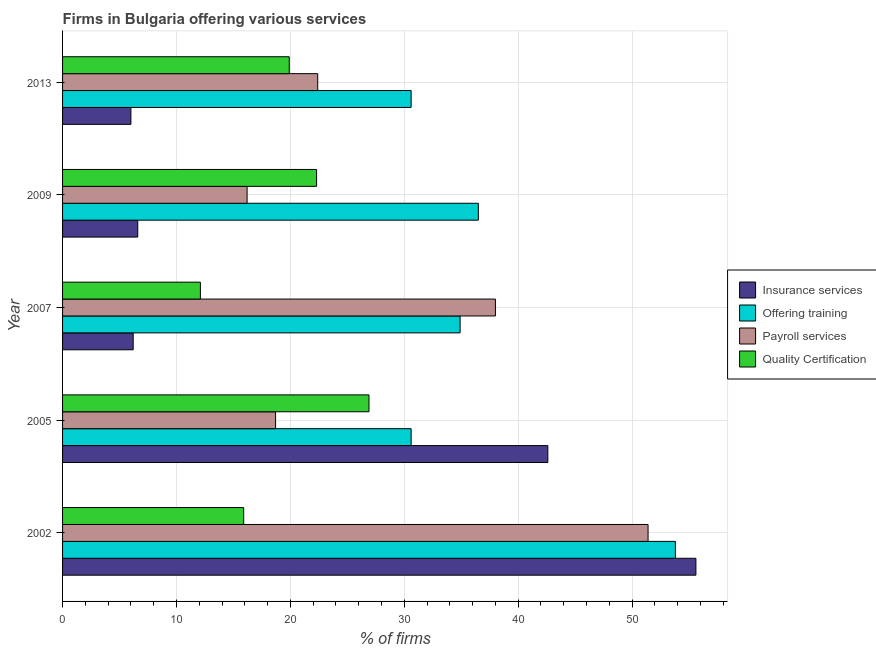Are the number of bars per tick equal to the number of legend labels?
Provide a succinct answer. Yes. Are the number of bars on each tick of the Y-axis equal?
Your answer should be very brief. Yes. How many bars are there on the 3rd tick from the top?
Give a very brief answer. 4. How many bars are there on the 3rd tick from the bottom?
Your response must be concise. 4. What is the label of the 5th group of bars from the top?
Your answer should be very brief. 2002. In how many cases, is the number of bars for a given year not equal to the number of legend labels?
Offer a very short reply. 0. What is the percentage of firms offering insurance services in 2002?
Your response must be concise. 55.6. Across all years, what is the maximum percentage of firms offering training?
Offer a very short reply. 53.8. In which year was the percentage of firms offering training maximum?
Provide a short and direct response. 2002. In which year was the percentage of firms offering payroll services minimum?
Your answer should be very brief. 2009. What is the total percentage of firms offering training in the graph?
Give a very brief answer. 186.4. What is the average percentage of firms offering payroll services per year?
Provide a succinct answer. 29.34. In the year 2007, what is the difference between the percentage of firms offering training and percentage of firms offering insurance services?
Your answer should be compact. 28.7. What is the ratio of the percentage of firms offering insurance services in 2002 to that in 2005?
Make the answer very short. 1.3. What is the difference between the highest and the lowest percentage of firms offering insurance services?
Offer a very short reply. 49.6. In how many years, is the percentage of firms offering insurance services greater than the average percentage of firms offering insurance services taken over all years?
Provide a succinct answer. 2. What does the 3rd bar from the top in 2007 represents?
Your answer should be very brief. Offering training. What does the 2nd bar from the bottom in 2009 represents?
Give a very brief answer. Offering training. How many bars are there?
Offer a terse response. 20. How many years are there in the graph?
Keep it short and to the point. 5. What is the difference between two consecutive major ticks on the X-axis?
Your answer should be compact. 10. Where does the legend appear in the graph?
Offer a very short reply. Center right. How are the legend labels stacked?
Provide a succinct answer. Vertical. What is the title of the graph?
Keep it short and to the point. Firms in Bulgaria offering various services . Does "Austria" appear as one of the legend labels in the graph?
Keep it short and to the point. No. What is the label or title of the X-axis?
Provide a short and direct response. % of firms. What is the label or title of the Y-axis?
Offer a very short reply. Year. What is the % of firms of Insurance services in 2002?
Provide a succinct answer. 55.6. What is the % of firms in Offering training in 2002?
Your answer should be very brief. 53.8. What is the % of firms in Payroll services in 2002?
Your answer should be compact. 51.4. What is the % of firms of Insurance services in 2005?
Offer a terse response. 42.6. What is the % of firms of Offering training in 2005?
Keep it short and to the point. 30.6. What is the % of firms of Payroll services in 2005?
Make the answer very short. 18.7. What is the % of firms of Quality Certification in 2005?
Your answer should be very brief. 26.9. What is the % of firms in Insurance services in 2007?
Keep it short and to the point. 6.2. What is the % of firms in Offering training in 2007?
Your answer should be compact. 34.9. What is the % of firms of Payroll services in 2007?
Give a very brief answer. 38. What is the % of firms of Insurance services in 2009?
Your response must be concise. 6.6. What is the % of firms in Offering training in 2009?
Ensure brevity in your answer.  36.5. What is the % of firms in Quality Certification in 2009?
Your response must be concise. 22.3. What is the % of firms in Insurance services in 2013?
Offer a very short reply. 6. What is the % of firms in Offering training in 2013?
Your answer should be very brief. 30.6. What is the % of firms in Payroll services in 2013?
Provide a short and direct response. 22.4. What is the % of firms in Quality Certification in 2013?
Keep it short and to the point. 19.9. Across all years, what is the maximum % of firms in Insurance services?
Make the answer very short. 55.6. Across all years, what is the maximum % of firms of Offering training?
Give a very brief answer. 53.8. Across all years, what is the maximum % of firms in Payroll services?
Provide a short and direct response. 51.4. Across all years, what is the maximum % of firms in Quality Certification?
Provide a succinct answer. 26.9. Across all years, what is the minimum % of firms of Insurance services?
Keep it short and to the point. 6. Across all years, what is the minimum % of firms in Offering training?
Your response must be concise. 30.6. Across all years, what is the minimum % of firms of Payroll services?
Your response must be concise. 16.2. Across all years, what is the minimum % of firms in Quality Certification?
Make the answer very short. 12.1. What is the total % of firms of Insurance services in the graph?
Your answer should be compact. 117. What is the total % of firms of Offering training in the graph?
Your answer should be compact. 186.4. What is the total % of firms of Payroll services in the graph?
Make the answer very short. 146.7. What is the total % of firms in Quality Certification in the graph?
Offer a very short reply. 97.1. What is the difference between the % of firms in Insurance services in 2002 and that in 2005?
Your response must be concise. 13. What is the difference between the % of firms in Offering training in 2002 and that in 2005?
Give a very brief answer. 23.2. What is the difference between the % of firms of Payroll services in 2002 and that in 2005?
Provide a succinct answer. 32.7. What is the difference between the % of firms of Quality Certification in 2002 and that in 2005?
Make the answer very short. -11. What is the difference between the % of firms of Insurance services in 2002 and that in 2007?
Your answer should be compact. 49.4. What is the difference between the % of firms of Payroll services in 2002 and that in 2007?
Offer a very short reply. 13.4. What is the difference between the % of firms of Quality Certification in 2002 and that in 2007?
Keep it short and to the point. 3.8. What is the difference between the % of firms in Payroll services in 2002 and that in 2009?
Offer a terse response. 35.2. What is the difference between the % of firms in Insurance services in 2002 and that in 2013?
Your answer should be compact. 49.6. What is the difference between the % of firms of Offering training in 2002 and that in 2013?
Give a very brief answer. 23.2. What is the difference between the % of firms in Payroll services in 2002 and that in 2013?
Your answer should be compact. 29. What is the difference between the % of firms of Insurance services in 2005 and that in 2007?
Your answer should be compact. 36.4. What is the difference between the % of firms in Offering training in 2005 and that in 2007?
Keep it short and to the point. -4.3. What is the difference between the % of firms of Payroll services in 2005 and that in 2007?
Keep it short and to the point. -19.3. What is the difference between the % of firms of Quality Certification in 2005 and that in 2007?
Offer a very short reply. 14.8. What is the difference between the % of firms of Insurance services in 2005 and that in 2013?
Keep it short and to the point. 36.6. What is the difference between the % of firms in Offering training in 2005 and that in 2013?
Make the answer very short. 0. What is the difference between the % of firms in Quality Certification in 2005 and that in 2013?
Provide a short and direct response. 7. What is the difference between the % of firms in Payroll services in 2007 and that in 2009?
Provide a short and direct response. 21.8. What is the difference between the % of firms of Quality Certification in 2007 and that in 2009?
Your response must be concise. -10.2. What is the difference between the % of firms of Offering training in 2007 and that in 2013?
Offer a terse response. 4.3. What is the difference between the % of firms of Payroll services in 2007 and that in 2013?
Give a very brief answer. 15.6. What is the difference between the % of firms in Insurance services in 2009 and that in 2013?
Give a very brief answer. 0.6. What is the difference between the % of firms of Payroll services in 2009 and that in 2013?
Keep it short and to the point. -6.2. What is the difference between the % of firms in Quality Certification in 2009 and that in 2013?
Offer a very short reply. 2.4. What is the difference between the % of firms of Insurance services in 2002 and the % of firms of Offering training in 2005?
Ensure brevity in your answer.  25. What is the difference between the % of firms of Insurance services in 2002 and the % of firms of Payroll services in 2005?
Make the answer very short. 36.9. What is the difference between the % of firms of Insurance services in 2002 and the % of firms of Quality Certification in 2005?
Your answer should be very brief. 28.7. What is the difference between the % of firms in Offering training in 2002 and the % of firms in Payroll services in 2005?
Offer a terse response. 35.1. What is the difference between the % of firms of Offering training in 2002 and the % of firms of Quality Certification in 2005?
Ensure brevity in your answer.  26.9. What is the difference between the % of firms in Insurance services in 2002 and the % of firms in Offering training in 2007?
Offer a terse response. 20.7. What is the difference between the % of firms in Insurance services in 2002 and the % of firms in Quality Certification in 2007?
Your response must be concise. 43.5. What is the difference between the % of firms of Offering training in 2002 and the % of firms of Quality Certification in 2007?
Make the answer very short. 41.7. What is the difference between the % of firms of Payroll services in 2002 and the % of firms of Quality Certification in 2007?
Provide a succinct answer. 39.3. What is the difference between the % of firms of Insurance services in 2002 and the % of firms of Payroll services in 2009?
Your response must be concise. 39.4. What is the difference between the % of firms in Insurance services in 2002 and the % of firms in Quality Certification in 2009?
Provide a short and direct response. 33.3. What is the difference between the % of firms of Offering training in 2002 and the % of firms of Payroll services in 2009?
Your response must be concise. 37.6. What is the difference between the % of firms of Offering training in 2002 and the % of firms of Quality Certification in 2009?
Provide a succinct answer. 31.5. What is the difference between the % of firms of Payroll services in 2002 and the % of firms of Quality Certification in 2009?
Give a very brief answer. 29.1. What is the difference between the % of firms in Insurance services in 2002 and the % of firms in Offering training in 2013?
Ensure brevity in your answer.  25. What is the difference between the % of firms of Insurance services in 2002 and the % of firms of Payroll services in 2013?
Offer a terse response. 33.2. What is the difference between the % of firms in Insurance services in 2002 and the % of firms in Quality Certification in 2013?
Your answer should be very brief. 35.7. What is the difference between the % of firms of Offering training in 2002 and the % of firms of Payroll services in 2013?
Ensure brevity in your answer.  31.4. What is the difference between the % of firms in Offering training in 2002 and the % of firms in Quality Certification in 2013?
Make the answer very short. 33.9. What is the difference between the % of firms in Payroll services in 2002 and the % of firms in Quality Certification in 2013?
Offer a terse response. 31.5. What is the difference between the % of firms of Insurance services in 2005 and the % of firms of Offering training in 2007?
Give a very brief answer. 7.7. What is the difference between the % of firms of Insurance services in 2005 and the % of firms of Payroll services in 2007?
Make the answer very short. 4.6. What is the difference between the % of firms of Insurance services in 2005 and the % of firms of Quality Certification in 2007?
Offer a terse response. 30.5. What is the difference between the % of firms of Payroll services in 2005 and the % of firms of Quality Certification in 2007?
Provide a short and direct response. 6.6. What is the difference between the % of firms in Insurance services in 2005 and the % of firms in Offering training in 2009?
Give a very brief answer. 6.1. What is the difference between the % of firms of Insurance services in 2005 and the % of firms of Payroll services in 2009?
Your answer should be compact. 26.4. What is the difference between the % of firms in Insurance services in 2005 and the % of firms in Quality Certification in 2009?
Make the answer very short. 20.3. What is the difference between the % of firms in Insurance services in 2005 and the % of firms in Payroll services in 2013?
Your response must be concise. 20.2. What is the difference between the % of firms in Insurance services in 2005 and the % of firms in Quality Certification in 2013?
Ensure brevity in your answer.  22.7. What is the difference between the % of firms in Offering training in 2005 and the % of firms in Quality Certification in 2013?
Provide a succinct answer. 10.7. What is the difference between the % of firms of Insurance services in 2007 and the % of firms of Offering training in 2009?
Offer a very short reply. -30.3. What is the difference between the % of firms of Insurance services in 2007 and the % of firms of Payroll services in 2009?
Ensure brevity in your answer.  -10. What is the difference between the % of firms in Insurance services in 2007 and the % of firms in Quality Certification in 2009?
Your answer should be compact. -16.1. What is the difference between the % of firms of Offering training in 2007 and the % of firms of Payroll services in 2009?
Keep it short and to the point. 18.7. What is the difference between the % of firms of Offering training in 2007 and the % of firms of Quality Certification in 2009?
Your answer should be compact. 12.6. What is the difference between the % of firms in Insurance services in 2007 and the % of firms in Offering training in 2013?
Keep it short and to the point. -24.4. What is the difference between the % of firms in Insurance services in 2007 and the % of firms in Payroll services in 2013?
Offer a very short reply. -16.2. What is the difference between the % of firms of Insurance services in 2007 and the % of firms of Quality Certification in 2013?
Offer a very short reply. -13.7. What is the difference between the % of firms in Payroll services in 2007 and the % of firms in Quality Certification in 2013?
Your response must be concise. 18.1. What is the difference between the % of firms of Insurance services in 2009 and the % of firms of Payroll services in 2013?
Your answer should be compact. -15.8. What is the difference between the % of firms of Offering training in 2009 and the % of firms of Quality Certification in 2013?
Offer a very short reply. 16.6. What is the average % of firms of Insurance services per year?
Provide a short and direct response. 23.4. What is the average % of firms of Offering training per year?
Your answer should be compact. 37.28. What is the average % of firms in Payroll services per year?
Provide a succinct answer. 29.34. What is the average % of firms in Quality Certification per year?
Your response must be concise. 19.42. In the year 2002, what is the difference between the % of firms in Insurance services and % of firms in Offering training?
Provide a short and direct response. 1.8. In the year 2002, what is the difference between the % of firms of Insurance services and % of firms of Payroll services?
Provide a succinct answer. 4.2. In the year 2002, what is the difference between the % of firms in Insurance services and % of firms in Quality Certification?
Provide a short and direct response. 39.7. In the year 2002, what is the difference between the % of firms of Offering training and % of firms of Quality Certification?
Provide a short and direct response. 37.9. In the year 2002, what is the difference between the % of firms in Payroll services and % of firms in Quality Certification?
Provide a short and direct response. 35.5. In the year 2005, what is the difference between the % of firms of Insurance services and % of firms of Payroll services?
Offer a very short reply. 23.9. In the year 2005, what is the difference between the % of firms in Insurance services and % of firms in Quality Certification?
Ensure brevity in your answer.  15.7. In the year 2005, what is the difference between the % of firms in Offering training and % of firms in Payroll services?
Offer a very short reply. 11.9. In the year 2005, what is the difference between the % of firms of Offering training and % of firms of Quality Certification?
Ensure brevity in your answer.  3.7. In the year 2007, what is the difference between the % of firms of Insurance services and % of firms of Offering training?
Keep it short and to the point. -28.7. In the year 2007, what is the difference between the % of firms of Insurance services and % of firms of Payroll services?
Keep it short and to the point. -31.8. In the year 2007, what is the difference between the % of firms of Insurance services and % of firms of Quality Certification?
Keep it short and to the point. -5.9. In the year 2007, what is the difference between the % of firms of Offering training and % of firms of Quality Certification?
Your answer should be compact. 22.8. In the year 2007, what is the difference between the % of firms in Payroll services and % of firms in Quality Certification?
Ensure brevity in your answer.  25.9. In the year 2009, what is the difference between the % of firms in Insurance services and % of firms in Offering training?
Keep it short and to the point. -29.9. In the year 2009, what is the difference between the % of firms in Insurance services and % of firms in Payroll services?
Your answer should be very brief. -9.6. In the year 2009, what is the difference between the % of firms of Insurance services and % of firms of Quality Certification?
Offer a terse response. -15.7. In the year 2009, what is the difference between the % of firms in Offering training and % of firms in Payroll services?
Ensure brevity in your answer.  20.3. In the year 2013, what is the difference between the % of firms in Insurance services and % of firms in Offering training?
Offer a terse response. -24.6. In the year 2013, what is the difference between the % of firms in Insurance services and % of firms in Payroll services?
Provide a short and direct response. -16.4. In the year 2013, what is the difference between the % of firms of Insurance services and % of firms of Quality Certification?
Make the answer very short. -13.9. In the year 2013, what is the difference between the % of firms in Offering training and % of firms in Payroll services?
Your answer should be compact. 8.2. In the year 2013, what is the difference between the % of firms in Offering training and % of firms in Quality Certification?
Your response must be concise. 10.7. In the year 2013, what is the difference between the % of firms of Payroll services and % of firms of Quality Certification?
Provide a short and direct response. 2.5. What is the ratio of the % of firms in Insurance services in 2002 to that in 2005?
Offer a very short reply. 1.31. What is the ratio of the % of firms of Offering training in 2002 to that in 2005?
Give a very brief answer. 1.76. What is the ratio of the % of firms in Payroll services in 2002 to that in 2005?
Your answer should be compact. 2.75. What is the ratio of the % of firms in Quality Certification in 2002 to that in 2005?
Keep it short and to the point. 0.59. What is the ratio of the % of firms in Insurance services in 2002 to that in 2007?
Your response must be concise. 8.97. What is the ratio of the % of firms in Offering training in 2002 to that in 2007?
Make the answer very short. 1.54. What is the ratio of the % of firms of Payroll services in 2002 to that in 2007?
Your response must be concise. 1.35. What is the ratio of the % of firms in Quality Certification in 2002 to that in 2007?
Ensure brevity in your answer.  1.31. What is the ratio of the % of firms in Insurance services in 2002 to that in 2009?
Keep it short and to the point. 8.42. What is the ratio of the % of firms of Offering training in 2002 to that in 2009?
Your response must be concise. 1.47. What is the ratio of the % of firms in Payroll services in 2002 to that in 2009?
Provide a succinct answer. 3.17. What is the ratio of the % of firms in Quality Certification in 2002 to that in 2009?
Offer a terse response. 0.71. What is the ratio of the % of firms of Insurance services in 2002 to that in 2013?
Offer a terse response. 9.27. What is the ratio of the % of firms in Offering training in 2002 to that in 2013?
Give a very brief answer. 1.76. What is the ratio of the % of firms in Payroll services in 2002 to that in 2013?
Your answer should be very brief. 2.29. What is the ratio of the % of firms of Quality Certification in 2002 to that in 2013?
Keep it short and to the point. 0.8. What is the ratio of the % of firms in Insurance services in 2005 to that in 2007?
Your answer should be very brief. 6.87. What is the ratio of the % of firms in Offering training in 2005 to that in 2007?
Your answer should be very brief. 0.88. What is the ratio of the % of firms of Payroll services in 2005 to that in 2007?
Offer a very short reply. 0.49. What is the ratio of the % of firms of Quality Certification in 2005 to that in 2007?
Provide a short and direct response. 2.22. What is the ratio of the % of firms in Insurance services in 2005 to that in 2009?
Your answer should be very brief. 6.45. What is the ratio of the % of firms of Offering training in 2005 to that in 2009?
Your response must be concise. 0.84. What is the ratio of the % of firms in Payroll services in 2005 to that in 2009?
Your answer should be compact. 1.15. What is the ratio of the % of firms in Quality Certification in 2005 to that in 2009?
Offer a very short reply. 1.21. What is the ratio of the % of firms of Payroll services in 2005 to that in 2013?
Keep it short and to the point. 0.83. What is the ratio of the % of firms of Quality Certification in 2005 to that in 2013?
Your answer should be very brief. 1.35. What is the ratio of the % of firms of Insurance services in 2007 to that in 2009?
Your answer should be very brief. 0.94. What is the ratio of the % of firms in Offering training in 2007 to that in 2009?
Make the answer very short. 0.96. What is the ratio of the % of firms in Payroll services in 2007 to that in 2009?
Your answer should be very brief. 2.35. What is the ratio of the % of firms in Quality Certification in 2007 to that in 2009?
Provide a short and direct response. 0.54. What is the ratio of the % of firms in Insurance services in 2007 to that in 2013?
Your answer should be very brief. 1.03. What is the ratio of the % of firms of Offering training in 2007 to that in 2013?
Your response must be concise. 1.14. What is the ratio of the % of firms of Payroll services in 2007 to that in 2013?
Provide a short and direct response. 1.7. What is the ratio of the % of firms in Quality Certification in 2007 to that in 2013?
Offer a very short reply. 0.61. What is the ratio of the % of firms of Offering training in 2009 to that in 2013?
Provide a short and direct response. 1.19. What is the ratio of the % of firms in Payroll services in 2009 to that in 2013?
Your answer should be very brief. 0.72. What is the ratio of the % of firms in Quality Certification in 2009 to that in 2013?
Offer a terse response. 1.12. What is the difference between the highest and the second highest % of firms of Insurance services?
Your answer should be compact. 13. What is the difference between the highest and the second highest % of firms in Quality Certification?
Offer a terse response. 4.6. What is the difference between the highest and the lowest % of firms in Insurance services?
Keep it short and to the point. 49.6. What is the difference between the highest and the lowest % of firms of Offering training?
Offer a very short reply. 23.2. What is the difference between the highest and the lowest % of firms of Payroll services?
Provide a short and direct response. 35.2. What is the difference between the highest and the lowest % of firms of Quality Certification?
Keep it short and to the point. 14.8. 